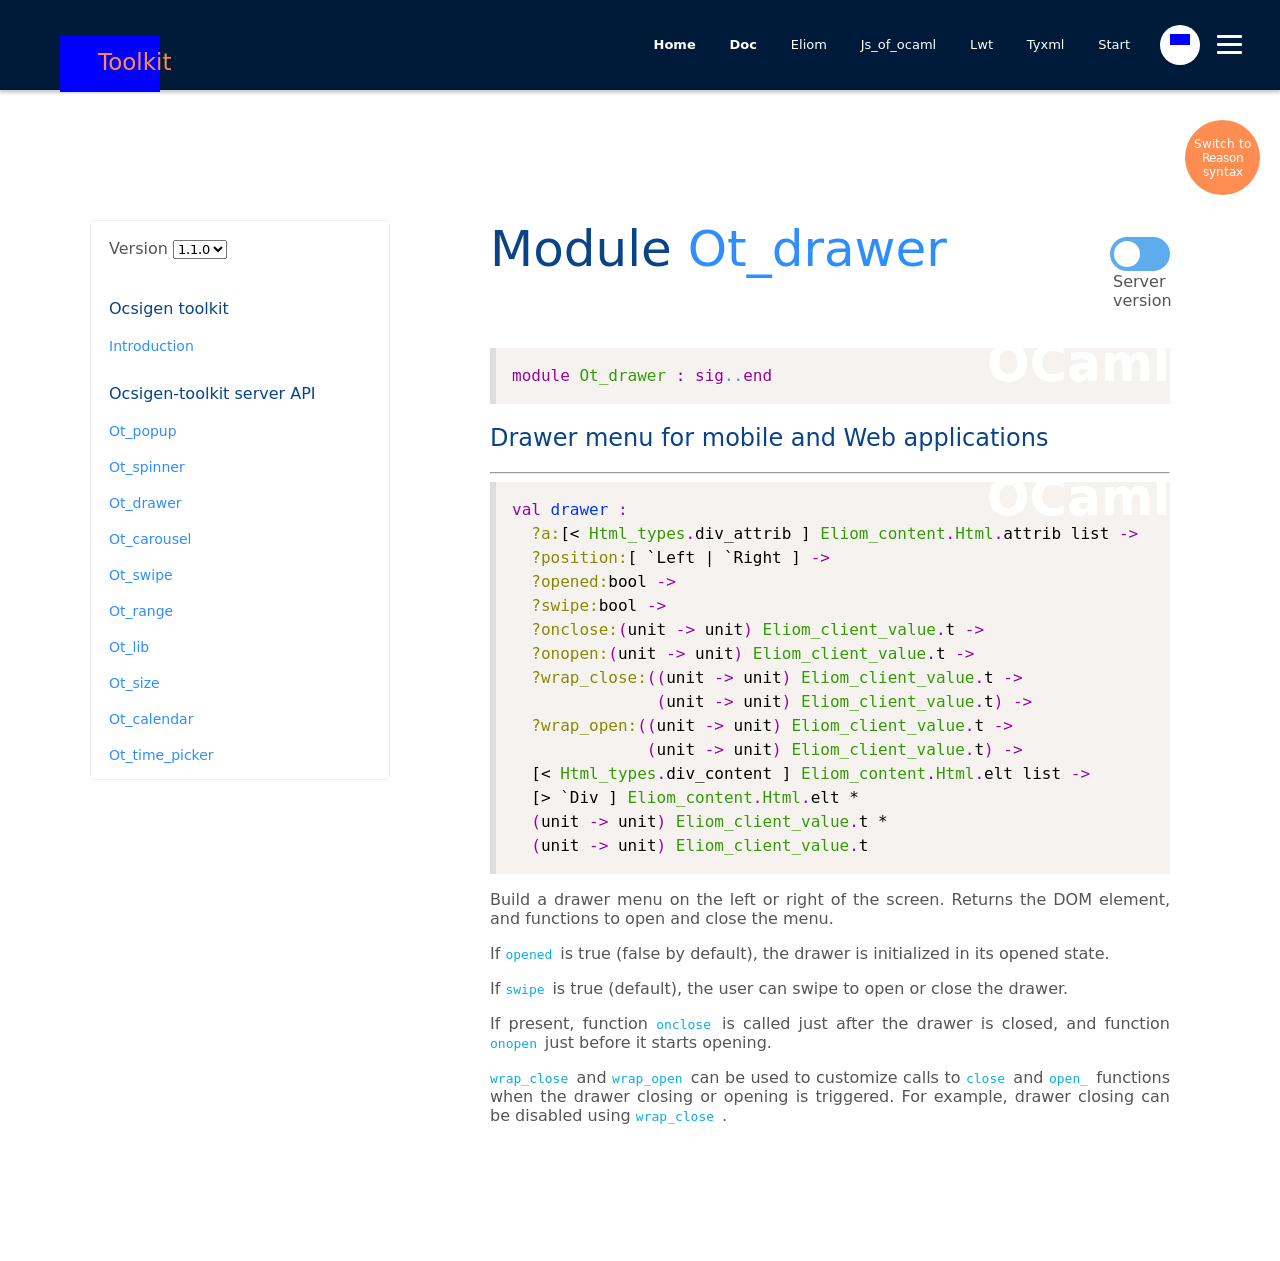Can you explain how the drawer functionality is integrated in mobile applications according to the image? According to the image, the drawer functionality in mobile applications can be integrated through parameters such as position (left or right), and attributes like 'opened' state, 'swipe' capability, and event handlers for 'onclose' and 'onopen'. This makes the drawer highly customizable, supporting user interactions through swiping and providing hooks for developers to define behaviors during its opening and closing. 